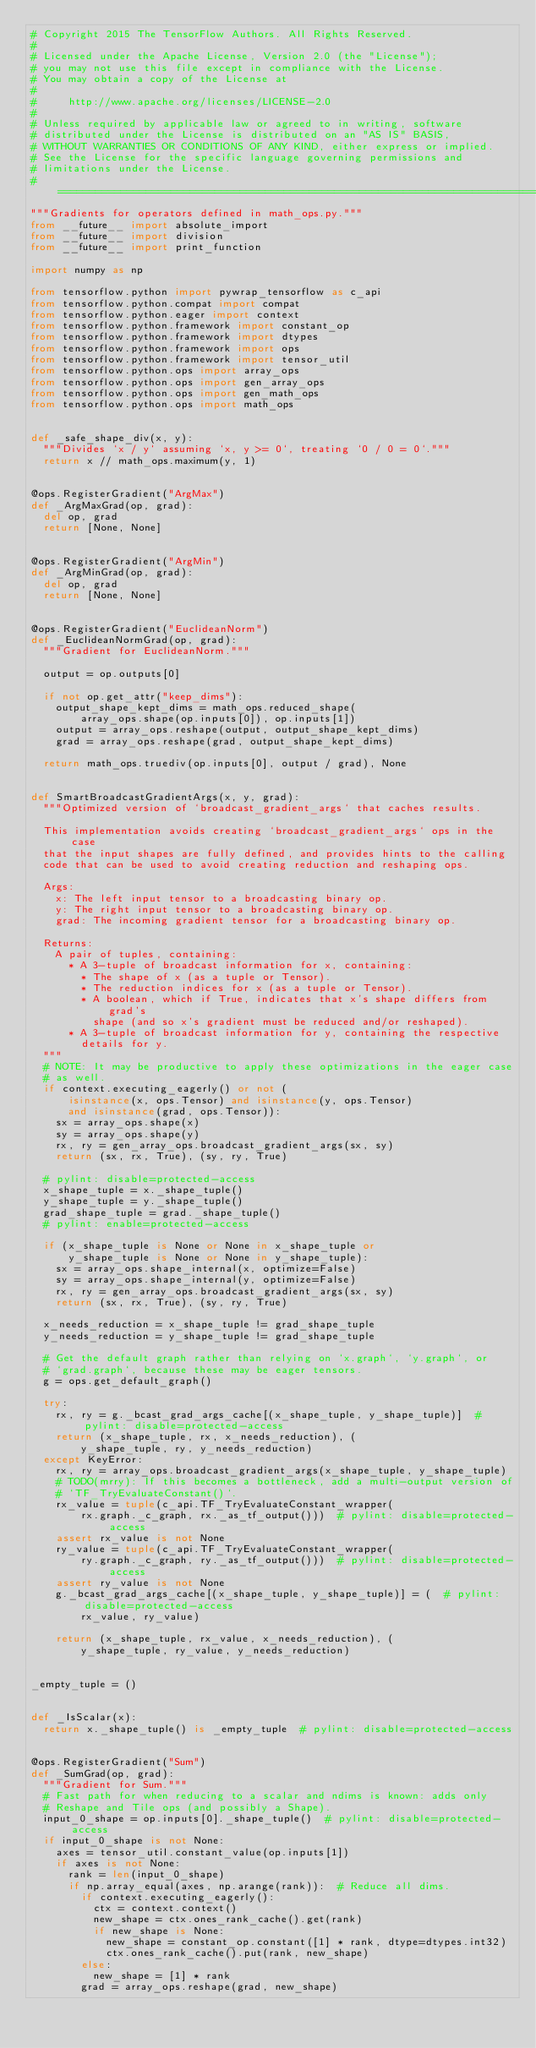Convert code to text. <code><loc_0><loc_0><loc_500><loc_500><_Python_># Copyright 2015 The TensorFlow Authors. All Rights Reserved.
#
# Licensed under the Apache License, Version 2.0 (the "License");
# you may not use this file except in compliance with the License.
# You may obtain a copy of the License at
#
#     http://www.apache.org/licenses/LICENSE-2.0
#
# Unless required by applicable law or agreed to in writing, software
# distributed under the License is distributed on an "AS IS" BASIS,
# WITHOUT WARRANTIES OR CONDITIONS OF ANY KIND, either express or implied.
# See the License for the specific language governing permissions and
# limitations under the License.
# ==============================================================================
"""Gradients for operators defined in math_ops.py."""
from __future__ import absolute_import
from __future__ import division
from __future__ import print_function

import numpy as np

from tensorflow.python import pywrap_tensorflow as c_api
from tensorflow.python.compat import compat
from tensorflow.python.eager import context
from tensorflow.python.framework import constant_op
from tensorflow.python.framework import dtypes
from tensorflow.python.framework import ops
from tensorflow.python.framework import tensor_util
from tensorflow.python.ops import array_ops
from tensorflow.python.ops import gen_array_ops
from tensorflow.python.ops import gen_math_ops
from tensorflow.python.ops import math_ops


def _safe_shape_div(x, y):
  """Divides `x / y` assuming `x, y >= 0`, treating `0 / 0 = 0`."""
  return x // math_ops.maximum(y, 1)


@ops.RegisterGradient("ArgMax")
def _ArgMaxGrad(op, grad):
  del op, grad
  return [None, None]


@ops.RegisterGradient("ArgMin")
def _ArgMinGrad(op, grad):
  del op, grad
  return [None, None]


@ops.RegisterGradient("EuclideanNorm")
def _EuclideanNormGrad(op, grad):
  """Gradient for EuclideanNorm."""

  output = op.outputs[0]

  if not op.get_attr("keep_dims"):
    output_shape_kept_dims = math_ops.reduced_shape(
        array_ops.shape(op.inputs[0]), op.inputs[1])
    output = array_ops.reshape(output, output_shape_kept_dims)
    grad = array_ops.reshape(grad, output_shape_kept_dims)

  return math_ops.truediv(op.inputs[0], output / grad), None


def SmartBroadcastGradientArgs(x, y, grad):
  """Optimized version of `broadcast_gradient_args` that caches results.

  This implementation avoids creating `broadcast_gradient_args` ops in the case
  that the input shapes are fully defined, and provides hints to the calling
  code that can be used to avoid creating reduction and reshaping ops.

  Args:
    x: The left input tensor to a broadcasting binary op.
    y: The right input tensor to a broadcasting binary op.
    grad: The incoming gradient tensor for a broadcasting binary op.

  Returns:
    A pair of tuples, containing:
      * A 3-tuple of broadcast information for x, containing:
        * The shape of x (as a tuple or Tensor).
        * The reduction indices for x (as a tuple or Tensor).
        * A boolean, which if True, indicates that x's shape differs from grad's
          shape (and so x's gradient must be reduced and/or reshaped).
      * A 3-tuple of broadcast information for y, containing the respective
        details for y.
  """
  # NOTE: It may be productive to apply these optimizations in the eager case
  # as well.
  if context.executing_eagerly() or not (
      isinstance(x, ops.Tensor) and isinstance(y, ops.Tensor)
      and isinstance(grad, ops.Tensor)):
    sx = array_ops.shape(x)
    sy = array_ops.shape(y)
    rx, ry = gen_array_ops.broadcast_gradient_args(sx, sy)
    return (sx, rx, True), (sy, ry, True)

  # pylint: disable=protected-access
  x_shape_tuple = x._shape_tuple()
  y_shape_tuple = y._shape_tuple()
  grad_shape_tuple = grad._shape_tuple()
  # pylint: enable=protected-access

  if (x_shape_tuple is None or None in x_shape_tuple or
      y_shape_tuple is None or None in y_shape_tuple):
    sx = array_ops.shape_internal(x, optimize=False)
    sy = array_ops.shape_internal(y, optimize=False)
    rx, ry = gen_array_ops.broadcast_gradient_args(sx, sy)
    return (sx, rx, True), (sy, ry, True)

  x_needs_reduction = x_shape_tuple != grad_shape_tuple
  y_needs_reduction = y_shape_tuple != grad_shape_tuple

  # Get the default graph rather than relying on `x.graph`, `y.graph`, or
  # `grad.graph`, because these may be eager tensors.
  g = ops.get_default_graph()

  try:
    rx, ry = g._bcast_grad_args_cache[(x_shape_tuple, y_shape_tuple)]  # pylint: disable=protected-access
    return (x_shape_tuple, rx, x_needs_reduction), (
        y_shape_tuple, ry, y_needs_reduction)
  except KeyError:
    rx, ry = array_ops.broadcast_gradient_args(x_shape_tuple, y_shape_tuple)
    # TODO(mrry): If this becomes a bottleneck, add a multi-output version of
    # `TF_TryEvaluateConstant()`.
    rx_value = tuple(c_api.TF_TryEvaluateConstant_wrapper(
        rx.graph._c_graph, rx._as_tf_output()))  # pylint: disable=protected-access
    assert rx_value is not None
    ry_value = tuple(c_api.TF_TryEvaluateConstant_wrapper(
        ry.graph._c_graph, ry._as_tf_output()))  # pylint: disable=protected-access
    assert ry_value is not None
    g._bcast_grad_args_cache[(x_shape_tuple, y_shape_tuple)] = (  # pylint: disable=protected-access
        rx_value, ry_value)

    return (x_shape_tuple, rx_value, x_needs_reduction), (
        y_shape_tuple, ry_value, y_needs_reduction)


_empty_tuple = ()


def _IsScalar(x):
  return x._shape_tuple() is _empty_tuple  # pylint: disable=protected-access


@ops.RegisterGradient("Sum")
def _SumGrad(op, grad):
  """Gradient for Sum."""
  # Fast path for when reducing to a scalar and ndims is known: adds only
  # Reshape and Tile ops (and possibly a Shape).
  input_0_shape = op.inputs[0]._shape_tuple()  # pylint: disable=protected-access
  if input_0_shape is not None:
    axes = tensor_util.constant_value(op.inputs[1])
    if axes is not None:
      rank = len(input_0_shape)
      if np.array_equal(axes, np.arange(rank)):  # Reduce all dims.
        if context.executing_eagerly():
          ctx = context.context()
          new_shape = ctx.ones_rank_cache().get(rank)
          if new_shape is None:
            new_shape = constant_op.constant([1] * rank, dtype=dtypes.int32)
            ctx.ones_rank_cache().put(rank, new_shape)
        else:
          new_shape = [1] * rank
        grad = array_ops.reshape(grad, new_shape)</code> 